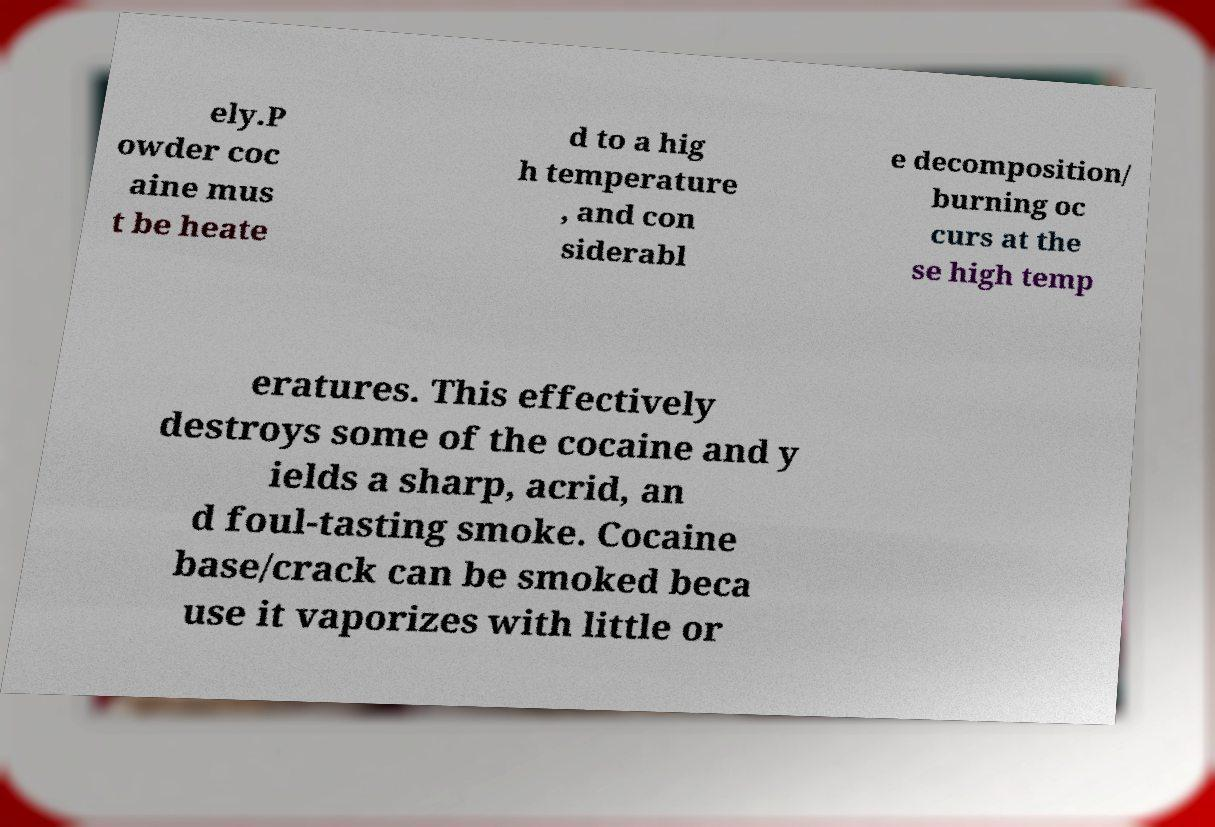Can you read and provide the text displayed in the image?This photo seems to have some interesting text. Can you extract and type it out for me? ely.P owder coc aine mus t be heate d to a hig h temperature , and con siderabl e decomposition/ burning oc curs at the se high temp eratures. This effectively destroys some of the cocaine and y ields a sharp, acrid, an d foul-tasting smoke. Cocaine base/crack can be smoked beca use it vaporizes with little or 